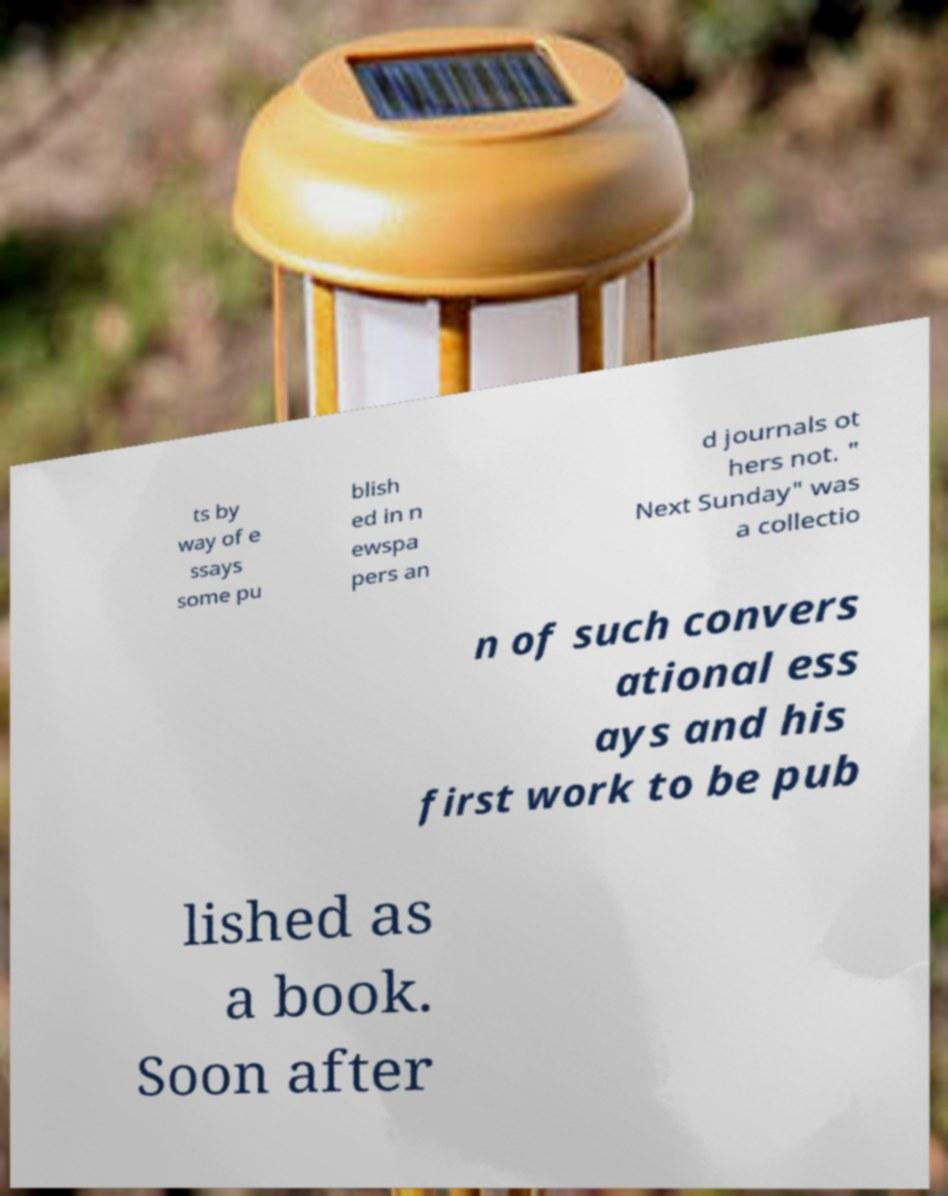What messages or text are displayed in this image? I need them in a readable, typed format. ts by way of e ssays some pu blish ed in n ewspa pers an d journals ot hers not. " Next Sunday" was a collectio n of such convers ational ess ays and his first work to be pub lished as a book. Soon after 